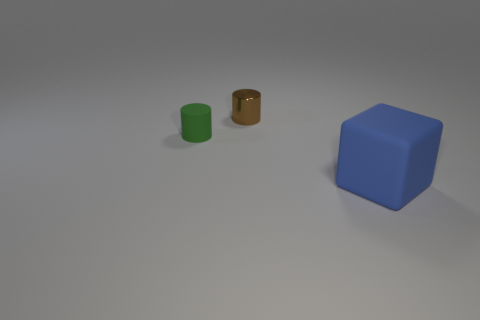Add 3 small metallic cylinders. How many objects exist? 6 Subtract all cubes. How many objects are left? 2 Add 1 cyan metal cubes. How many cyan metal cubes exist? 1 Subtract 0 purple blocks. How many objects are left? 3 Subtract all tiny yellow cubes. Subtract all small green rubber objects. How many objects are left? 2 Add 2 metallic objects. How many metallic objects are left? 3 